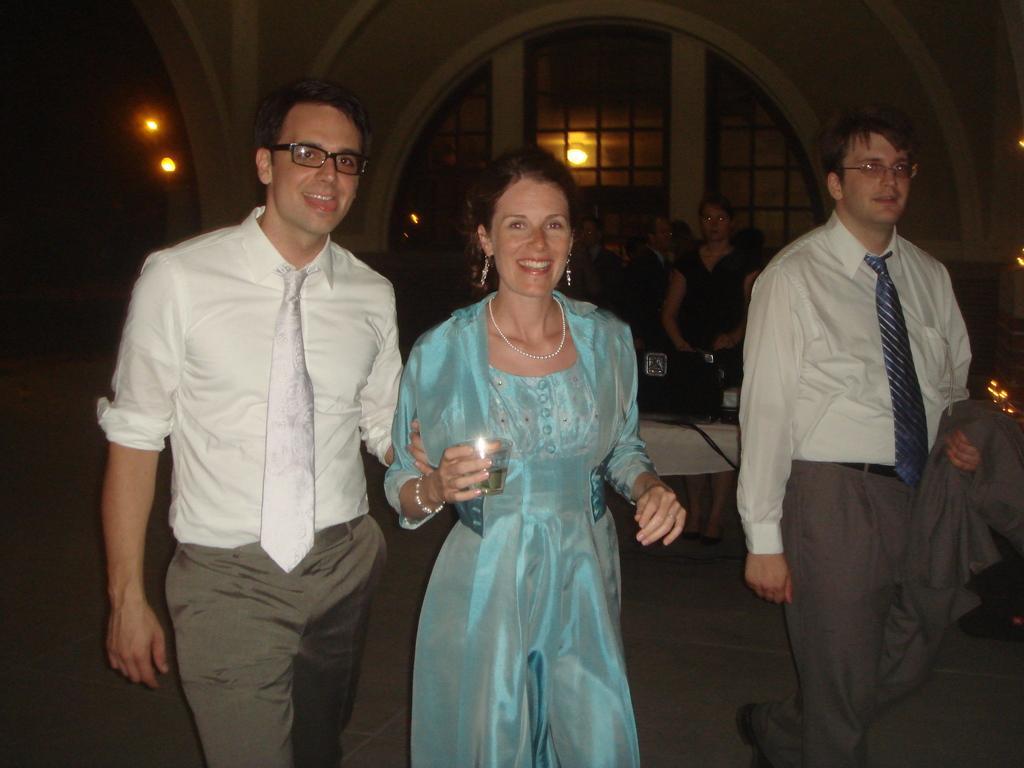Please provide a concise description of this image. In this image there are group of persons standing, there is a man walking towards the right of the image, he is holding an object, there is a woman standing, she is holding a glass, there are windows, there are lights, there is a wall, there are tables on the ground, there is an object towards the right of the image. 